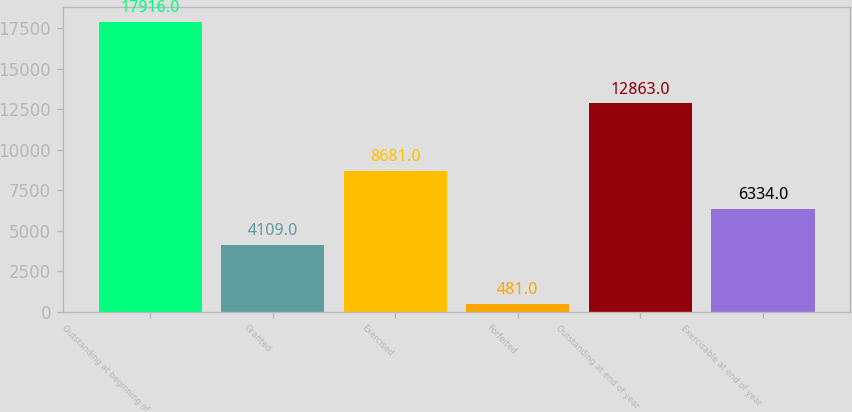<chart> <loc_0><loc_0><loc_500><loc_500><bar_chart><fcel>Outstanding at beginning of<fcel>Granted<fcel>Exercised<fcel>Forfeited<fcel>Outstanding at end of year<fcel>Exercisable at end of year<nl><fcel>17916<fcel>4109<fcel>8681<fcel>481<fcel>12863<fcel>6334<nl></chart> 